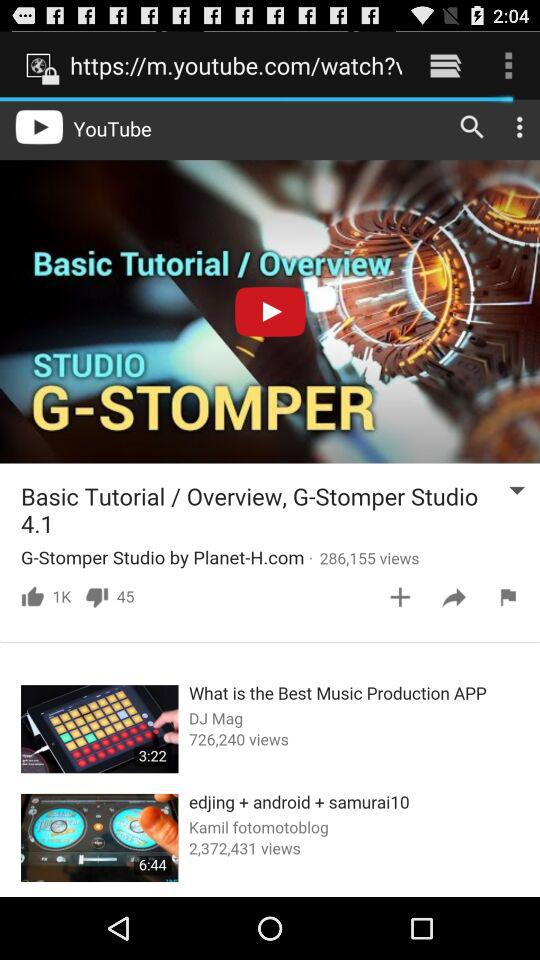How many views are for "What is the Best Music Production App?" The views are 726,240. 